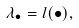<formula> <loc_0><loc_0><loc_500><loc_500>\lambda _ { \bullet } = l ( \bullet ) ,</formula> 